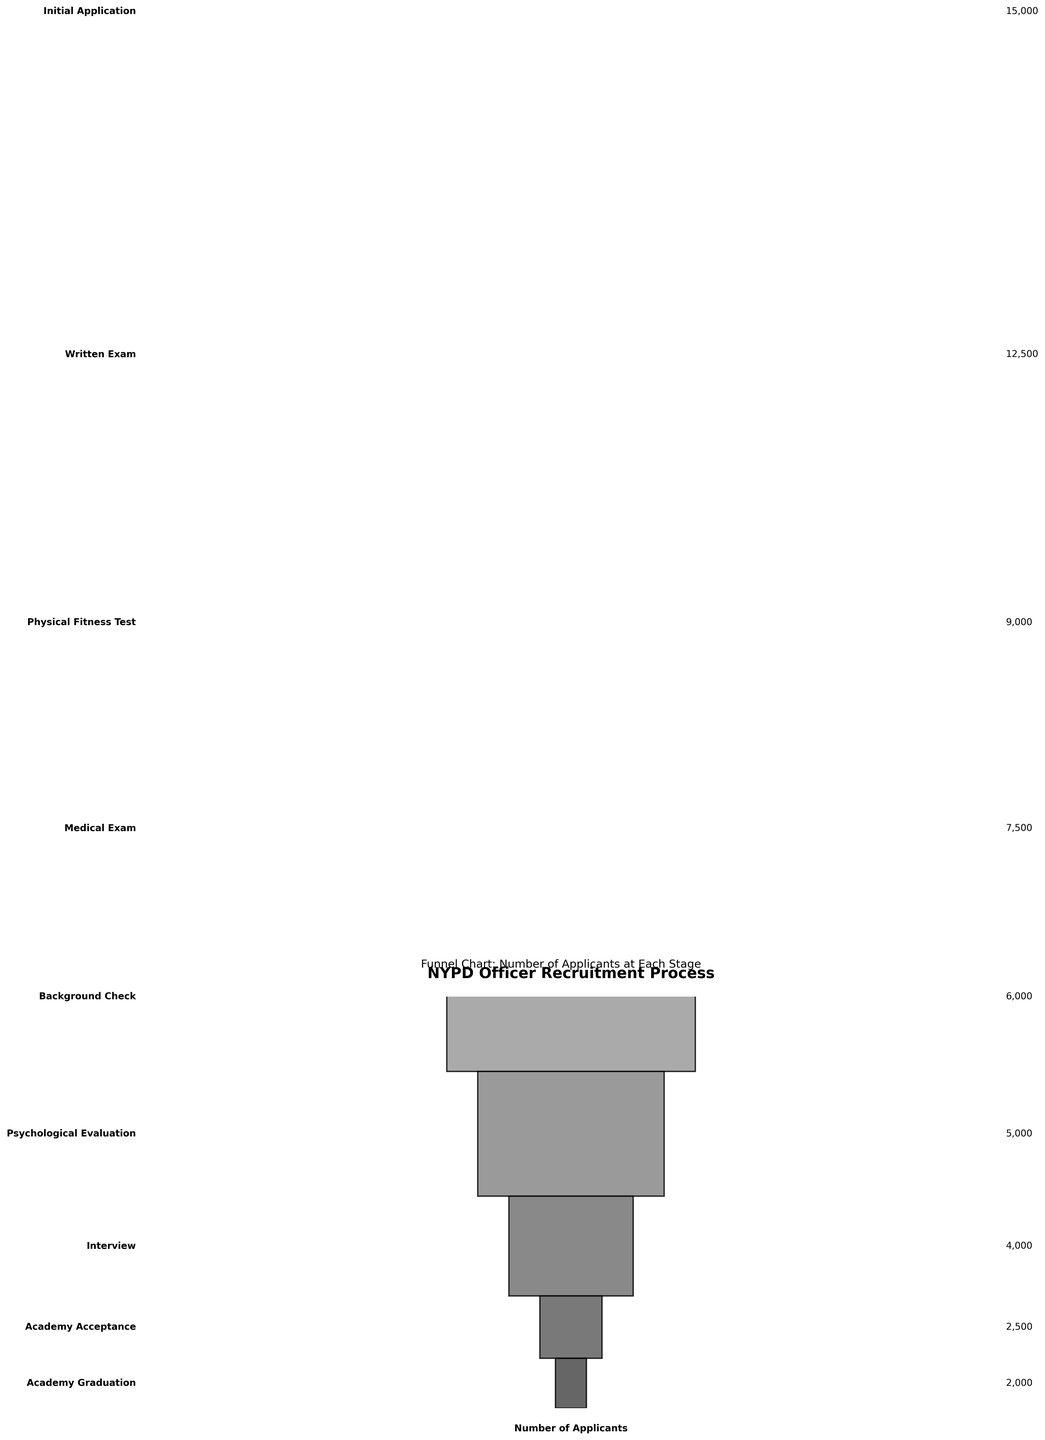Which stage has the highest number of applicants? The highest number of applicants is at the 'Initial Application' stage as it is at the top of the funnel with 15,000 applicants.
Answer: Initial Application What is the title of the funnel chart? The title of the funnel chart is clearly stated at the top: 'NYPD Officer Recruitment Process'.
Answer: NYPD Officer Recruitment Process How many applicants pass the psychological evaluation? The number of applicants who pass the psychological evaluation is found on the right side of the funnel, listed as 5,000.
Answer: 5,000 What is the difference in the number of applicants between the Written Exam and the Physical Fitness Test stages? The number of applicants for the Written Exam stage is 12,500 and for the Physical Fitness Test is 9,000. The difference is 12,500 - 9,000 = 3,500.
Answer: 3,500 How many stages are included in the funnel chart? The funnel chart lists each stage of the recruitment process, totaling 9 stages.
Answer: 9 Which stage directly follows the Medical Exam stage? The stage following the Medical Exam is the Background Check, as shown sequentially in the chart.
Answer: Background Check What percentage of applicants from the Initial Application stage reach the Academy Graduation stage? There are 15,000 applicants at the Initial Application stage and 2,000 at the Academy Graduation stage. The percentage is calculated as (2,000 / 15,000) * 100 = 13.33%.
Answer: 13.33% How many applicants are accepted into the academy after the Interview stage? After the Interview stage, the number of applicants accepted into the academy is indicated as 2,500.
Answer: 2,500 Which stage sees the largest drop in the number of applicants? The largest drop in applicants occurs between the Written Exam (12,500) and the Physical Fitness Test (9,000). The drop is 12,500 - 9,000 = 3,500.
Answer: Written Exam to Physical Fitness Test Out of the total applicants who begin the process, what fraction complete the Academy Graduation? The number of initial applicants is 15,000 and those who graduate the academy is 2,000, making the fraction 2,000/15,000 = 2/15.
Answer: 2/15 